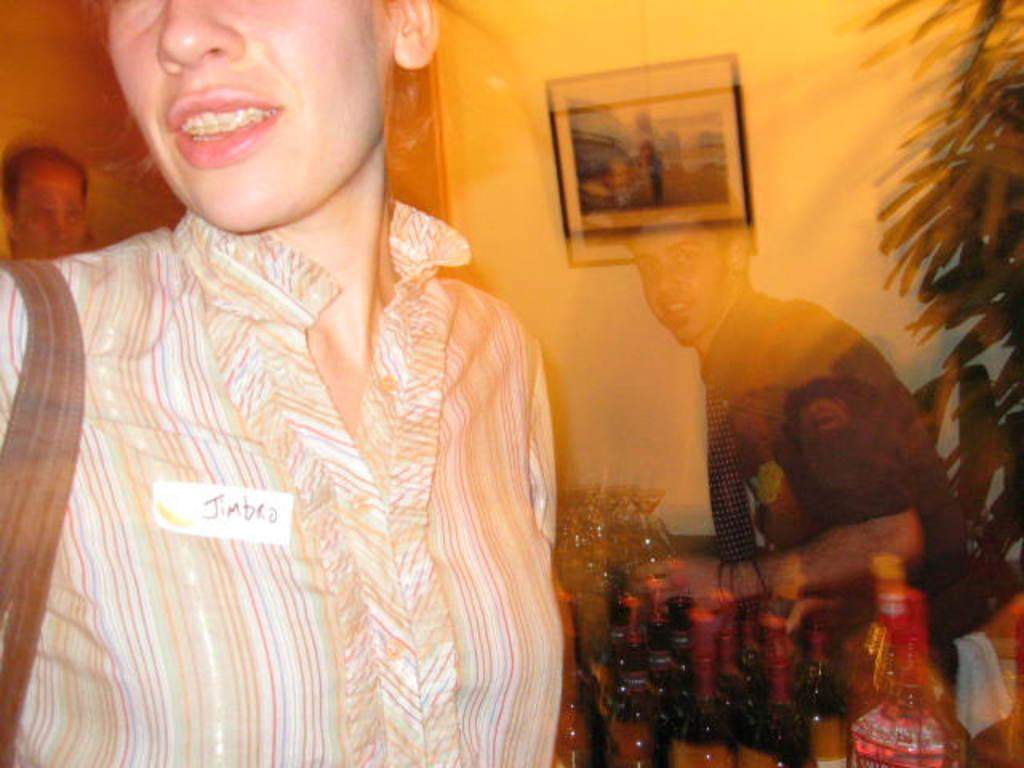What are the people in the image wearing? The people in the image are wearing clothes. What objects can be seen related to beverages in the image? There are bottles and wine glasses in the image. What type of vegetation is present in the image? There are leaves in the image. What is attached to the wall in the image? There is a frame stick to the wall in the image. How many ghosts are present in the image? There are no ghosts present in the image. What type of snails can be seen crawling on the clothes of the people in the image? There are no snails present in the image. 